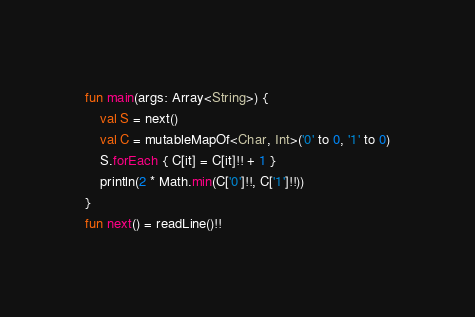<code> <loc_0><loc_0><loc_500><loc_500><_Kotlin_>fun main(args: Array<String>) {
    val S = next()
    val C = mutableMapOf<Char, Int>('0' to 0, '1' to 0)
    S.forEach { C[it] = C[it]!! + 1 }
    println(2 * Math.min(C['0']!!, C['1']!!))
}
fun next() = readLine()!!</code> 